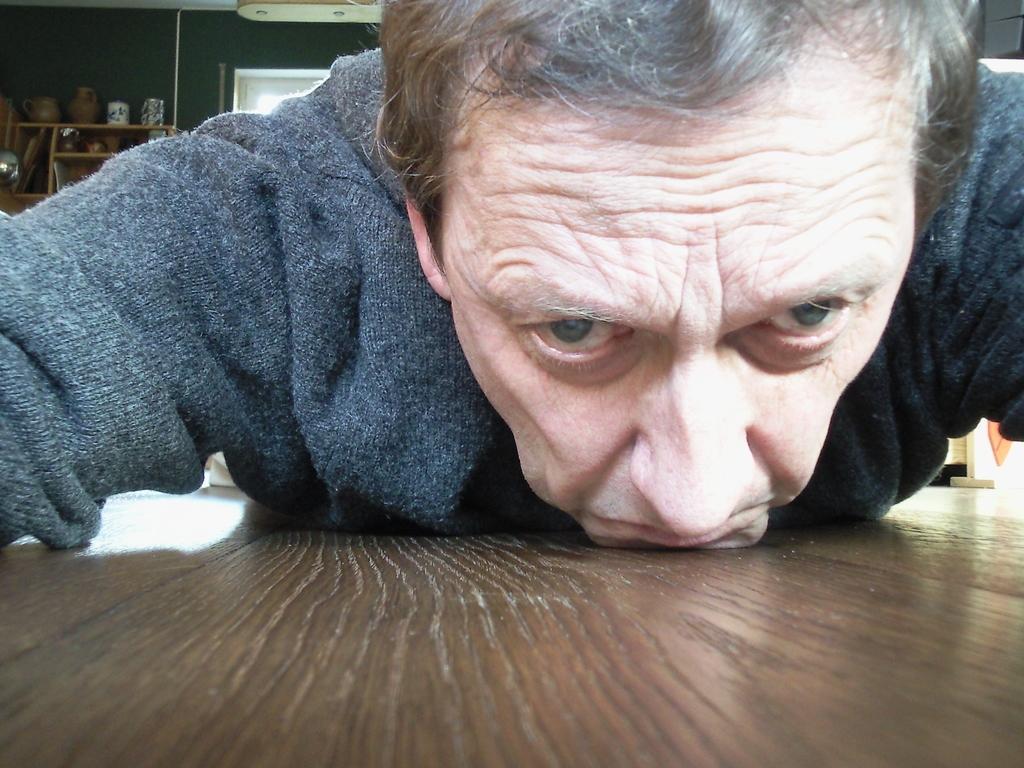Describe this image in one or two sentences. In this picture I can see a man laying on a wooden object, and in the background there are some objects in and on the rack, and there is a wall. 